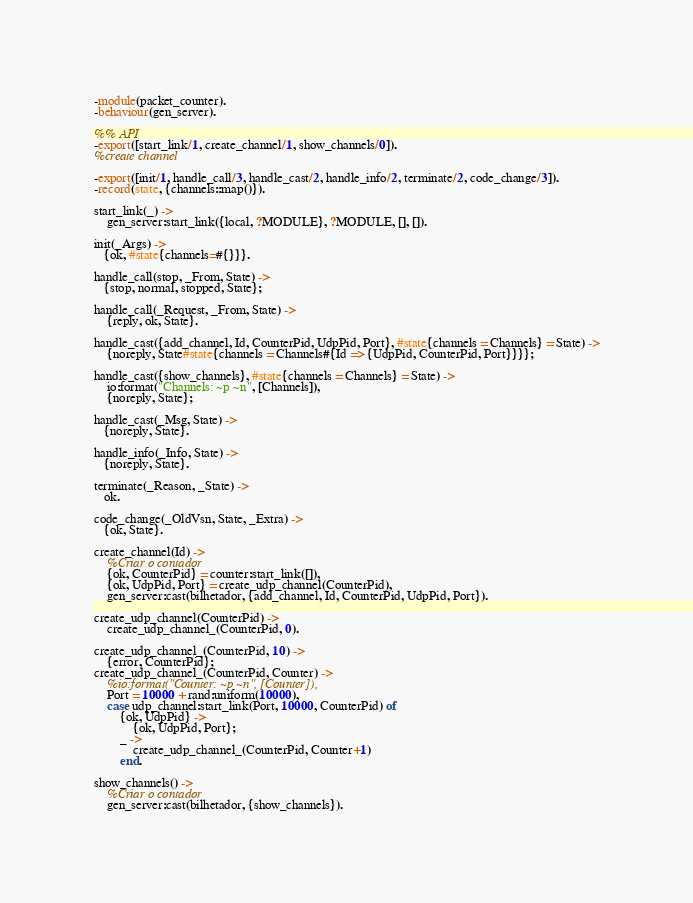Convert code to text. <code><loc_0><loc_0><loc_500><loc_500><_Erlang_>-module(packet_counter).
-behaviour(gen_server).

%% API
-export([start_link/1, create_channel/1, show_channels/0]).
%create channel

-export([init/1, handle_call/3, handle_cast/2, handle_info/2, terminate/2, code_change/3]).
-record(state, {channels::map()}).

start_link(_) ->
    gen_server:start_link({local, ?MODULE}, ?MODULE, [], []).

init(_Args) ->
   {ok, #state{channels=#{}}}.

handle_call(stop, _From, State) ->
   {stop, normal, stopped, State};

handle_call(_Request, _From, State) ->
    {reply, ok, State}.

handle_cast({add_channel, Id, CounterPid, UdpPid, Port}, #state{channels = Channels} = State) ->
    {noreply, State#state{channels = Channels#{Id => {UdpPid, CounterPid, Port}}}};

handle_cast({show_channels}, #state{channels = Channels} = State) ->
    io:format("Channels: ~p ~n", [Channels]),
    {noreply, State};

handle_cast(_Msg, State) ->
   {noreply, State}.

handle_info(_Info, State) ->
   {noreply, State}.

terminate(_Reason, _State) ->
   ok.

code_change(_OldVsn, State, _Extra) ->
   {ok, State}.

create_channel(Id) ->
    %Criar o contador
    {ok, CounterPid} = counter:start_link([]),
    {ok, UdpPid, Port} = create_udp_channel(CounterPid),
    gen_server:cast(bilhetador, {add_channel, Id, CounterPid, UdpPid, Port}).

create_udp_channel(CounterPid) ->
    create_udp_channel_(CounterPid, 0).

create_udp_channel_(CounterPid, 10) ->
    {error, CounterPid};
create_udp_channel_(CounterPid, Counter) ->
    %io:format("Counter: ~p ~n", [Counter]),
    Port = 10000 + rand:uniform(10000),
    case udp_channel:start_link(Port, 10000, CounterPid) of 
        {ok, UdpPid} -> 
            {ok, UdpPid, Port};
        _ ->
            create_udp_channel_(CounterPid, Counter+1)
        end.

show_channels() ->
    %Criar o contador
    gen_server:cast(bilhetador, {show_channels}).
</code> 